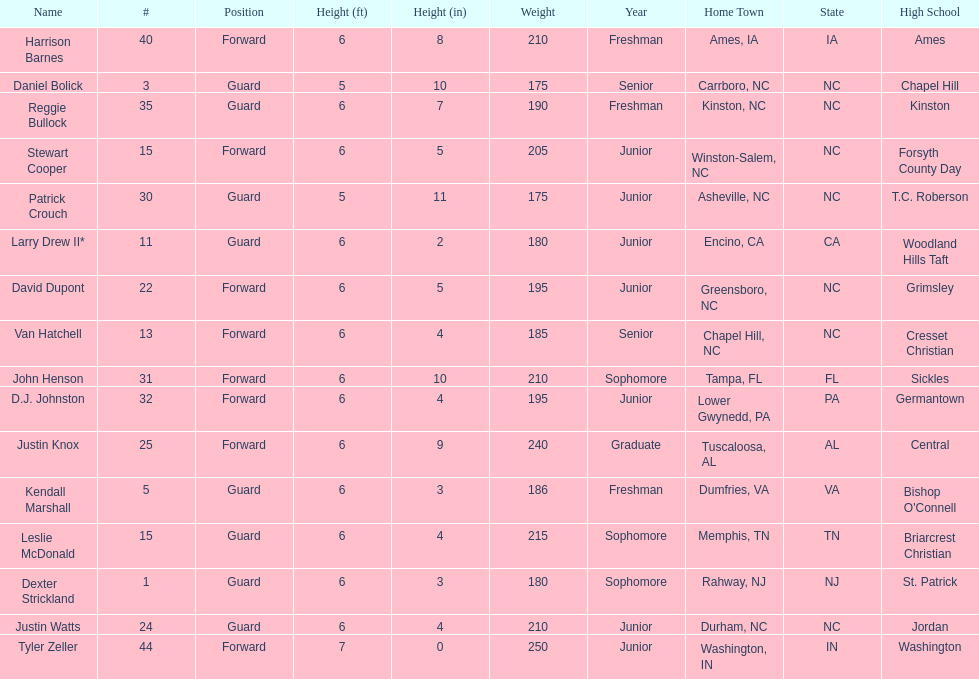How many players were taller than van hatchell? 7. 